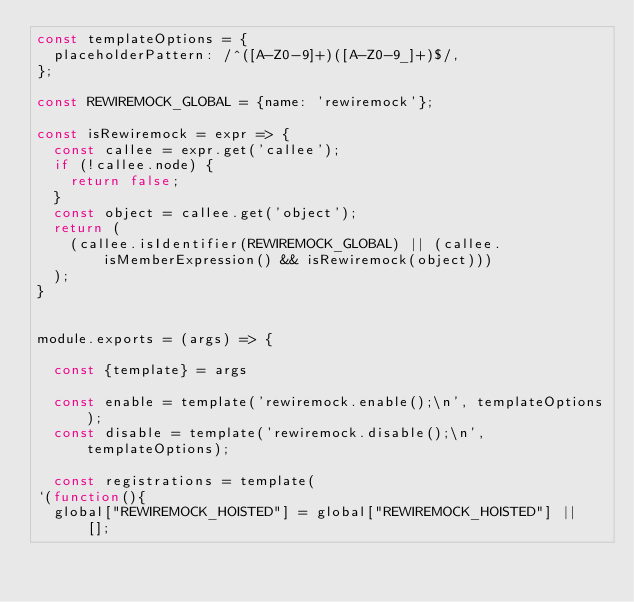Convert code to text. <code><loc_0><loc_0><loc_500><loc_500><_JavaScript_>const templateOptions = {
  placeholderPattern: /^([A-Z0-9]+)([A-Z0-9_]+)$/,
};

const REWIREMOCK_GLOBAL = {name: 'rewiremock'};

const isRewiremock = expr => {
  const callee = expr.get('callee');
  if (!callee.node) {
    return false;
  }
  const object = callee.get('object');
  return (
    (callee.isIdentifier(REWIREMOCK_GLOBAL) || (callee.isMemberExpression() && isRewiremock(object)))
  );
}


module.exports = (args) => {

  const {template} = args

  const enable = template('rewiremock.enable();\n', templateOptions);
  const disable = template('rewiremock.disable();\n', templateOptions);

  const registrations = template(
`(function(){
  global["REWIREMOCK_HOISTED"] = global["REWIREMOCK_HOISTED"] || [];</code> 